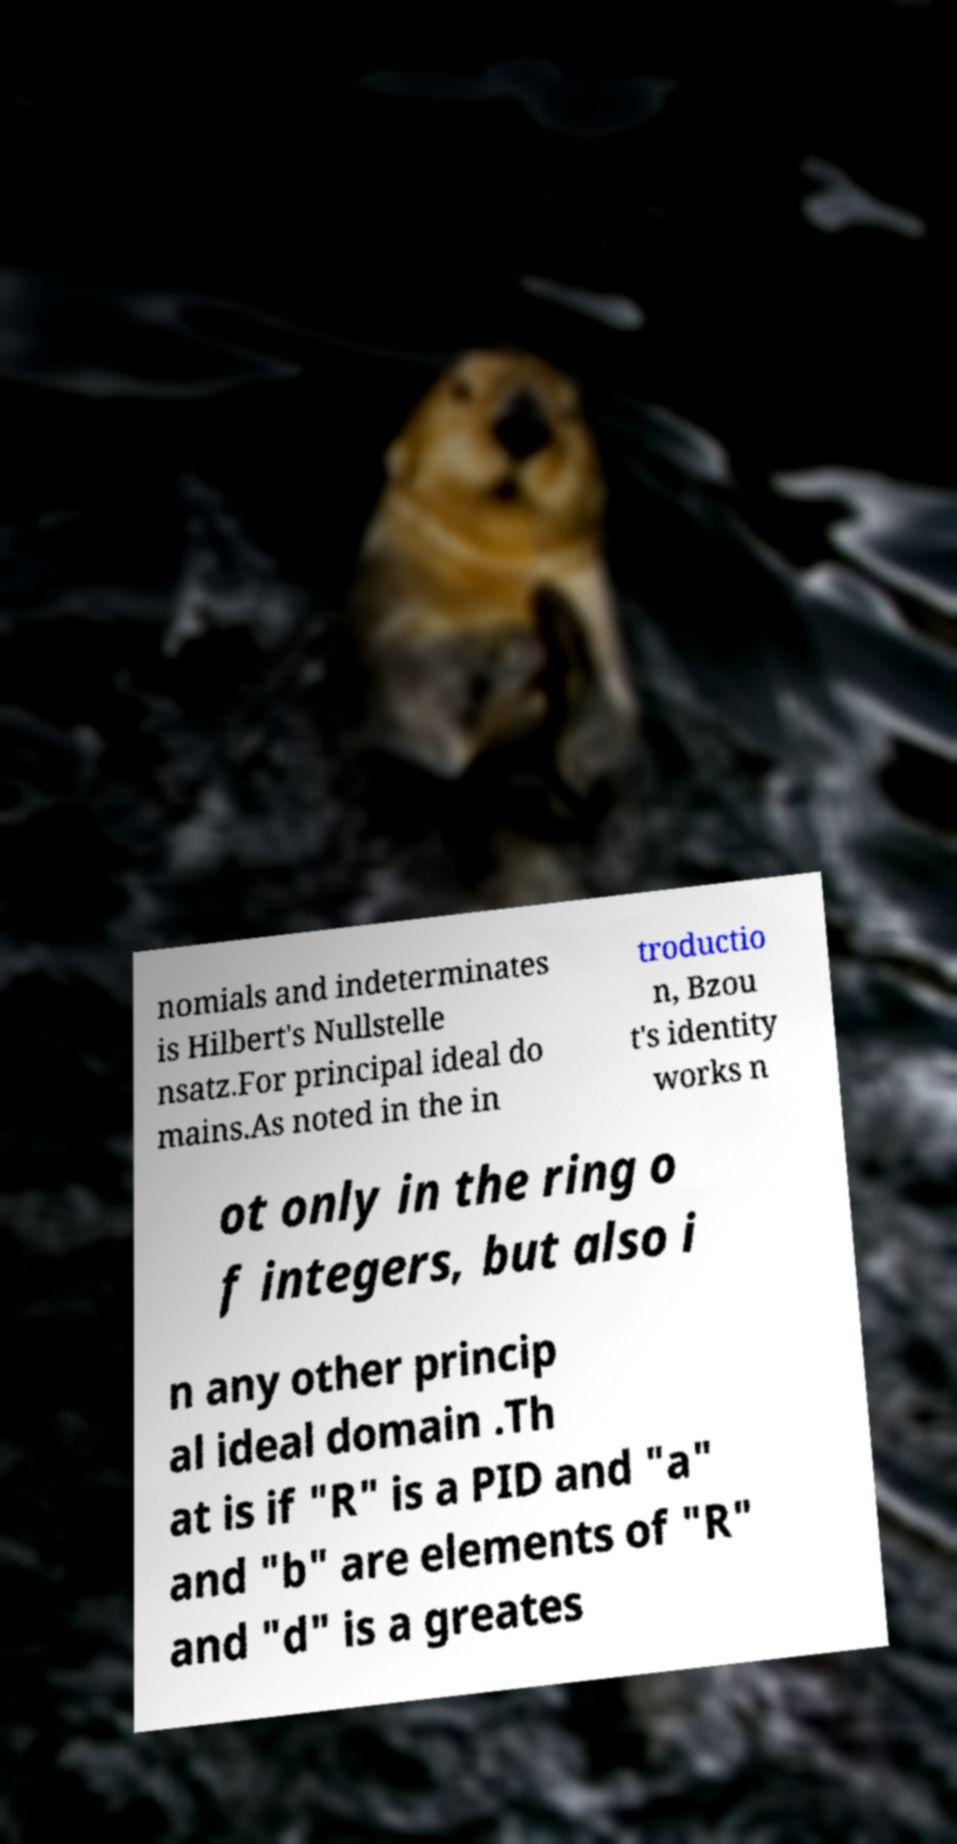There's text embedded in this image that I need extracted. Can you transcribe it verbatim? nomials and indeterminates is Hilbert's Nullstelle nsatz.For principal ideal do mains.As noted in the in troductio n, Bzou t's identity works n ot only in the ring o f integers, but also i n any other princip al ideal domain .Th at is if "R" is a PID and "a" and "b" are elements of "R" and "d" is a greates 